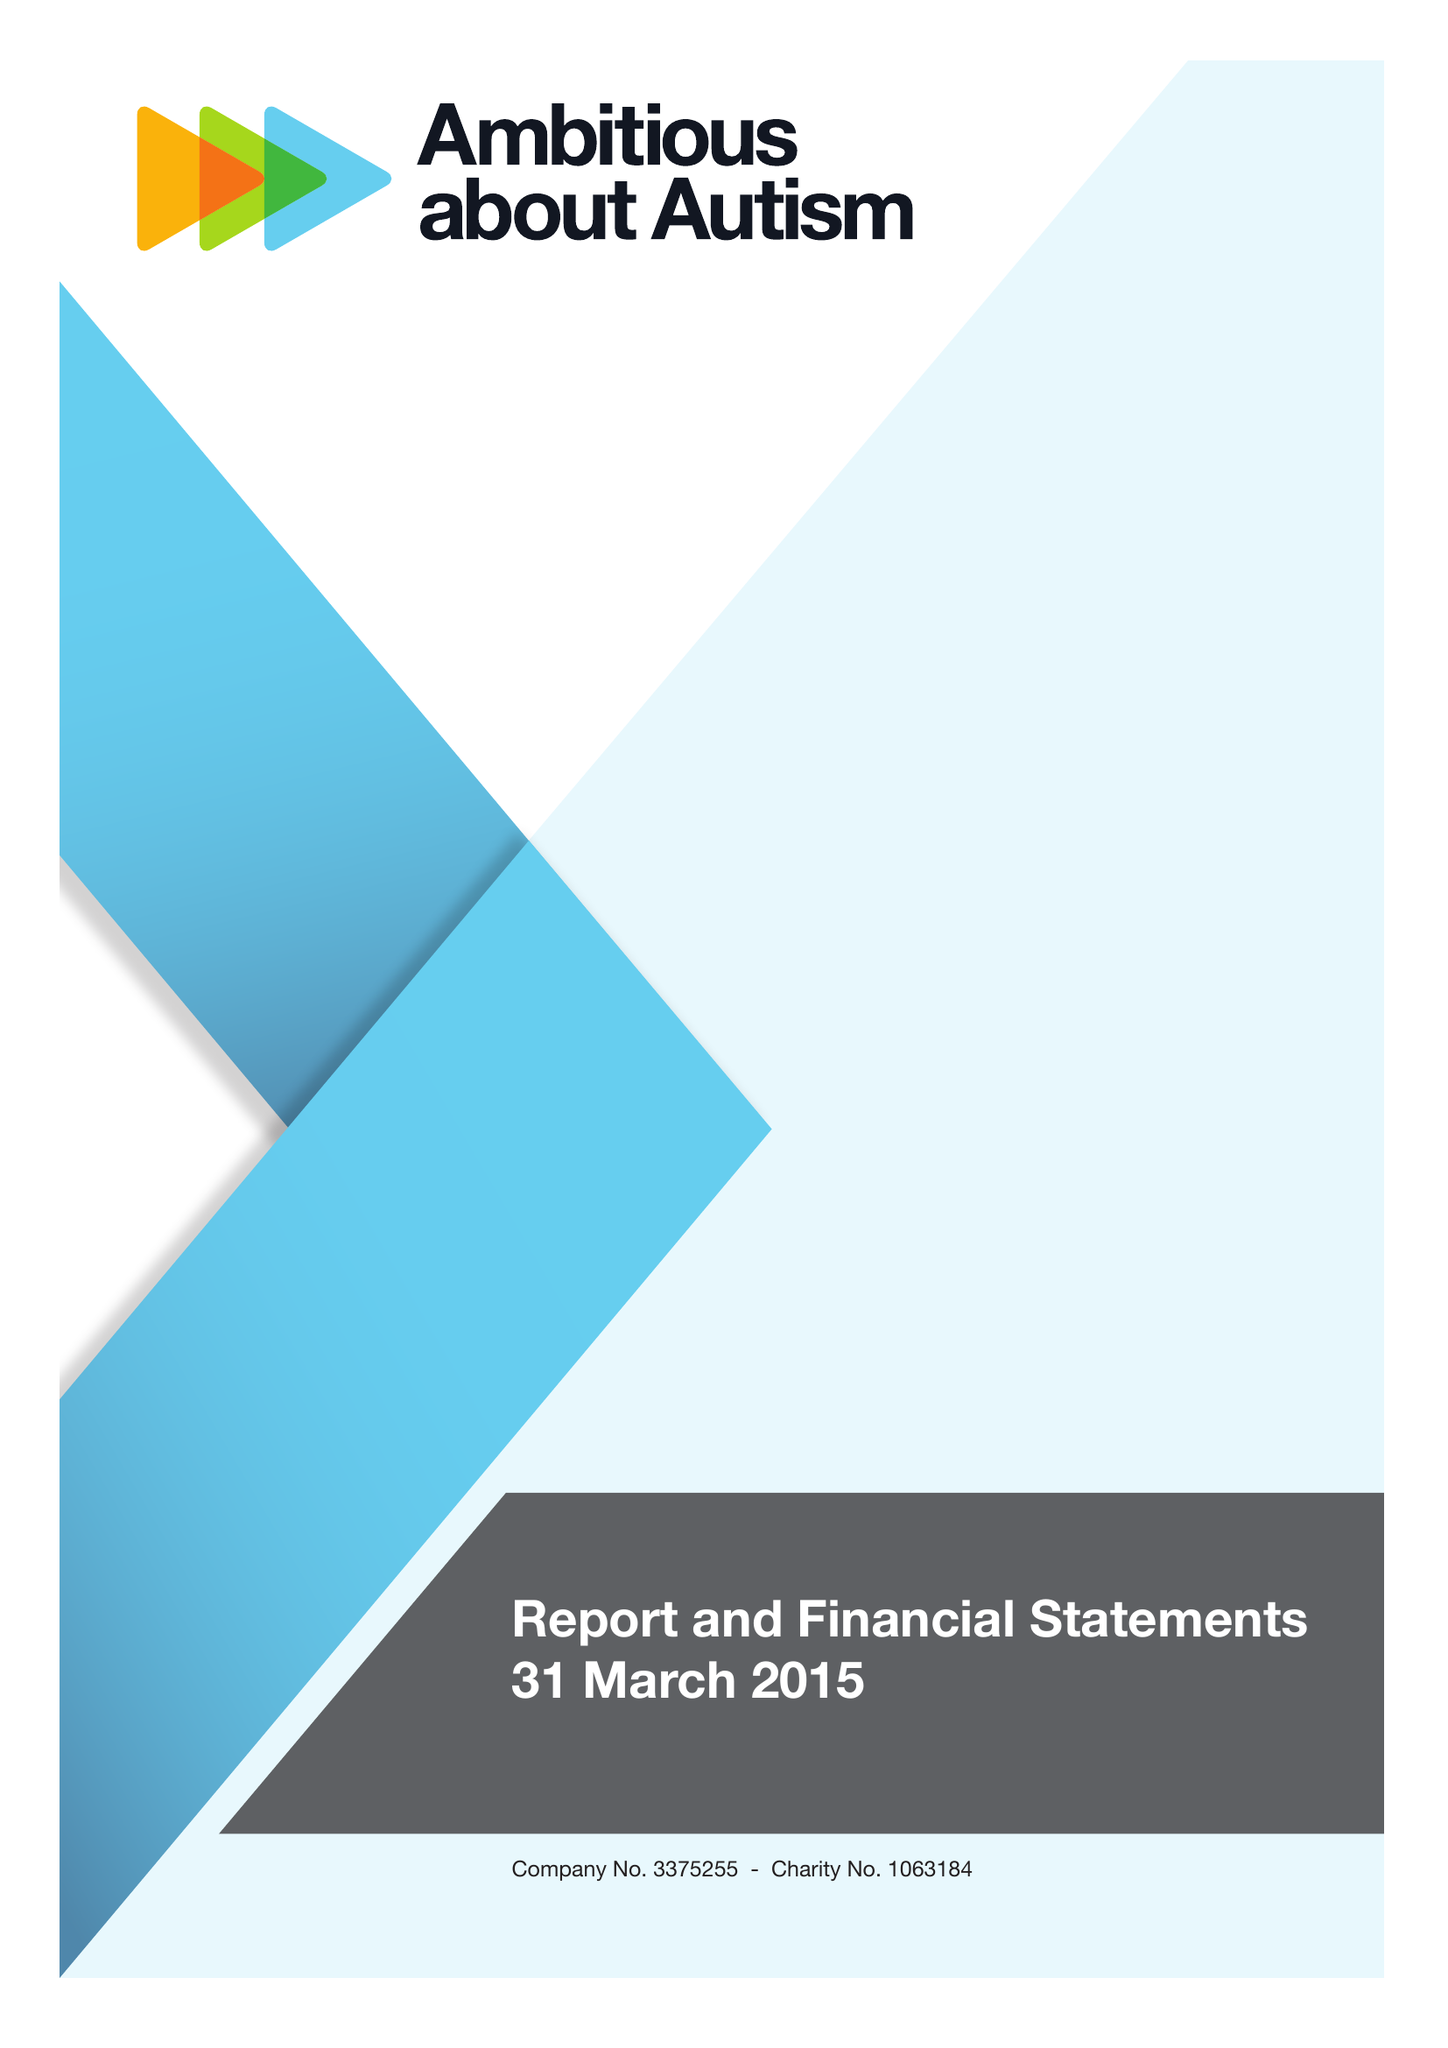What is the value for the charity_name?
Answer the question using a single word or phrase. Ambitious About Autism 